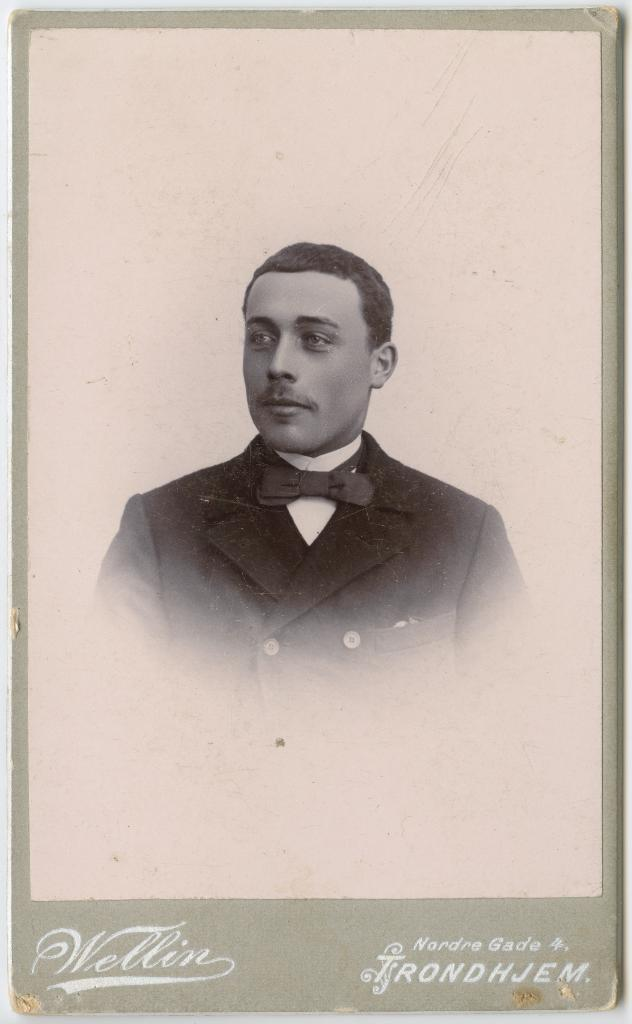What is depicted on the poster in the image? The poster features a man in the image. What is the man wearing in the poster? The man is wearing a black coat in the poster. Is there any text on the poster? Yes, there is text at the bottom of the poster. What type of fishing rod is the man holding in the image? There is no fishing rod present in the image; the man is wearing a black coat and there is text at the bottom of the poster. 